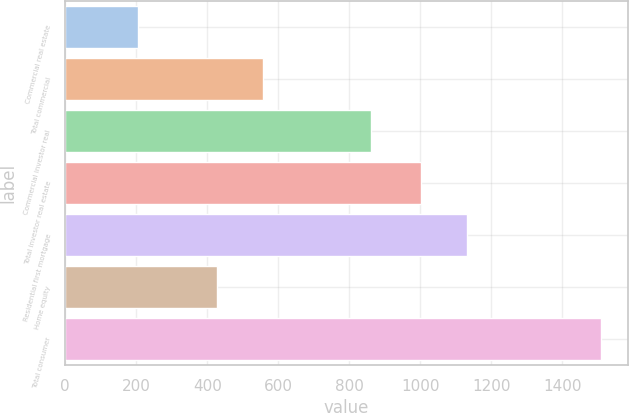Convert chart to OTSL. <chart><loc_0><loc_0><loc_500><loc_500><bar_chart><fcel>Commercial real estate<fcel>Total commercial<fcel>Commercial investor real<fcel>Total investor real estate<fcel>Residential first mortgage<fcel>Home equity<fcel>Total consumer<nl><fcel>205<fcel>558.4<fcel>862<fcel>1002<fcel>1132.4<fcel>428<fcel>1509<nl></chart> 